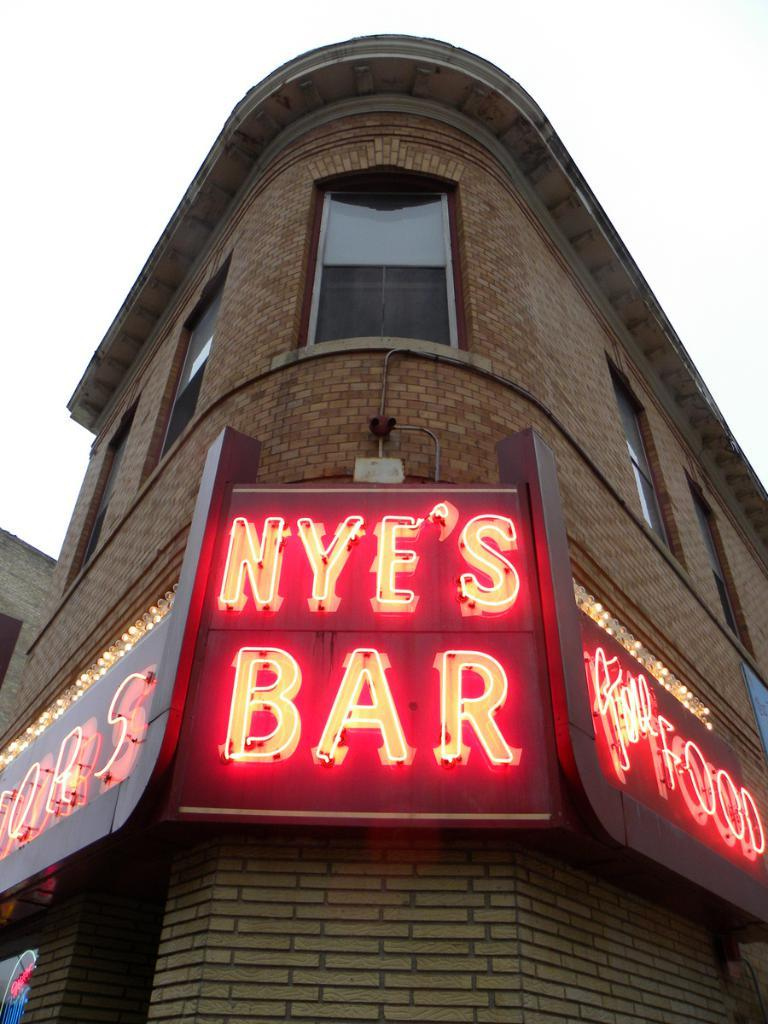What structure is present in the image? There is a building in the image. What is written on the building? There is text written on the building. What architectural feature can be seen on the building? There are windows visible on the building. What type of substance is being used to start a baseball game in the image? There is no substance or baseball game present in the image. How many baseballs can be seen in the image? There are no baseballs present in the image. 